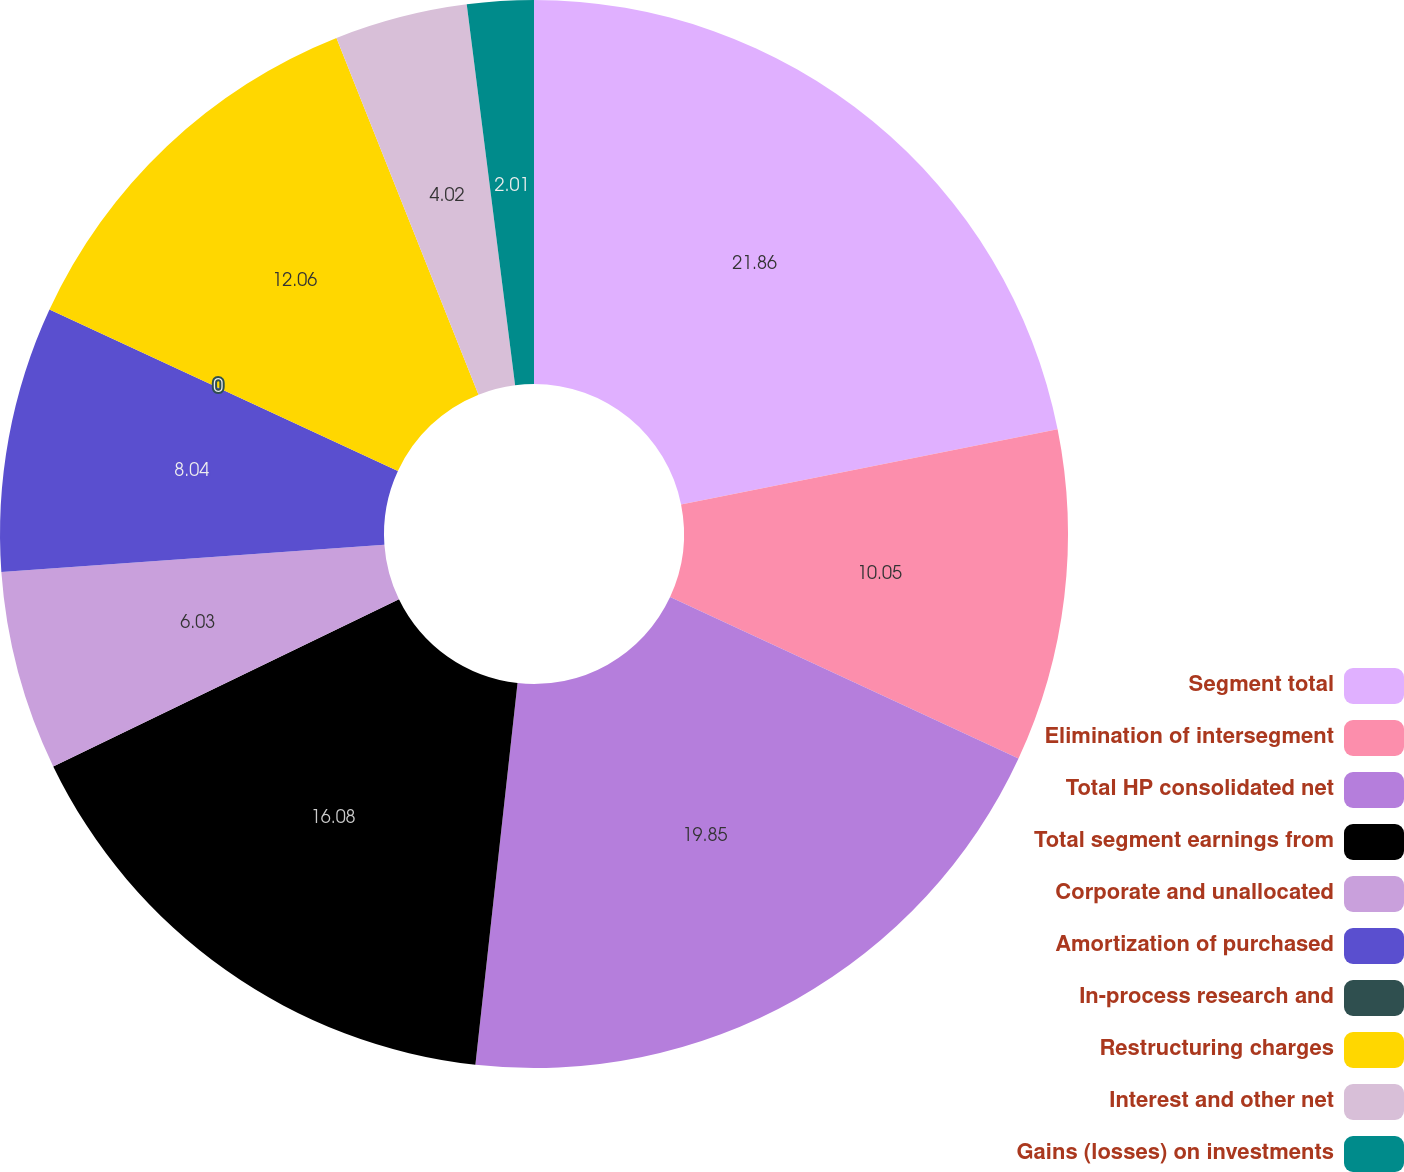<chart> <loc_0><loc_0><loc_500><loc_500><pie_chart><fcel>Segment total<fcel>Elimination of intersegment<fcel>Total HP consolidated net<fcel>Total segment earnings from<fcel>Corporate and unallocated<fcel>Amortization of purchased<fcel>In-process research and<fcel>Restructuring charges<fcel>Interest and other net<fcel>Gains (losses) on investments<nl><fcel>21.85%<fcel>10.05%<fcel>19.84%<fcel>16.08%<fcel>6.03%<fcel>8.04%<fcel>0.0%<fcel>12.06%<fcel>4.02%<fcel>2.01%<nl></chart> 